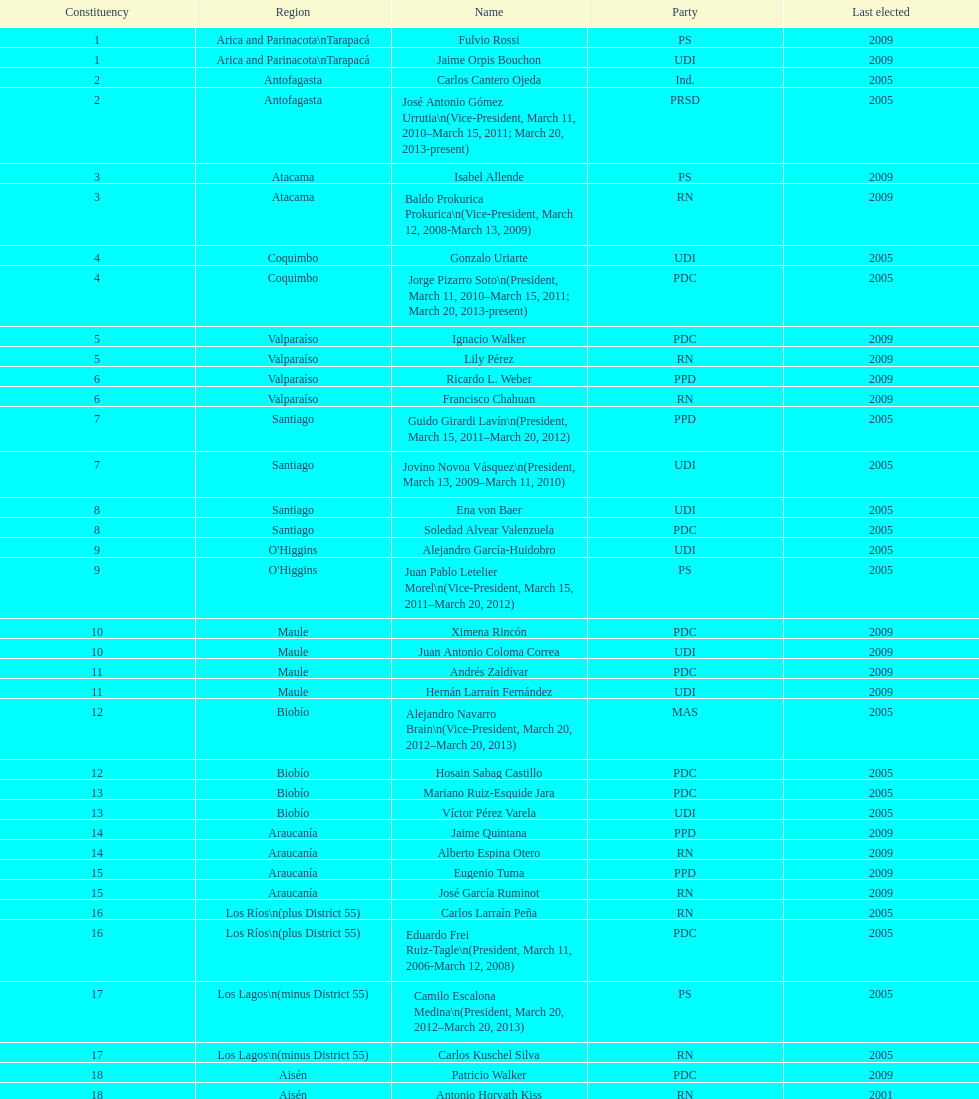Help me parse the entirety of this table. {'header': ['Constituency', 'Region', 'Name', 'Party', 'Last elected'], 'rows': [['1', 'Arica and Parinacota\\nTarapacá', 'Fulvio Rossi', 'PS', '2009'], ['1', 'Arica and Parinacota\\nTarapacá', 'Jaime Orpis Bouchon', 'UDI', '2009'], ['2', 'Antofagasta', 'Carlos Cantero Ojeda', 'Ind.', '2005'], ['2', 'Antofagasta', 'José Antonio Gómez Urrutia\\n(Vice-President, March 11, 2010–March 15, 2011; March 20, 2013-present)', 'PRSD', '2005'], ['3', 'Atacama', 'Isabel Allende', 'PS', '2009'], ['3', 'Atacama', 'Baldo Prokurica Prokurica\\n(Vice-President, March 12, 2008-March 13, 2009)', 'RN', '2009'], ['4', 'Coquimbo', 'Gonzalo Uriarte', 'UDI', '2005'], ['4', 'Coquimbo', 'Jorge Pizarro Soto\\n(President, March 11, 2010–March 15, 2011; March 20, 2013-present)', 'PDC', '2005'], ['5', 'Valparaíso', 'Ignacio Walker', 'PDC', '2009'], ['5', 'Valparaíso', 'Lily Pérez', 'RN', '2009'], ['6', 'Valparaíso', 'Ricardo L. Weber', 'PPD', '2009'], ['6', 'Valparaíso', 'Francisco Chahuan', 'RN', '2009'], ['7', 'Santiago', 'Guido Girardi Lavín\\n(President, March 15, 2011–March 20, 2012)', 'PPD', '2005'], ['7', 'Santiago', 'Jovino Novoa Vásquez\\n(President, March 13, 2009–March 11, 2010)', 'UDI', '2005'], ['8', 'Santiago', 'Ena von Baer', 'UDI', '2005'], ['8', 'Santiago', 'Soledad Alvear Valenzuela', 'PDC', '2005'], ['9', "O'Higgins", 'Alejandro García-Huidobro', 'UDI', '2005'], ['9', "O'Higgins", 'Juan Pablo Letelier Morel\\n(Vice-President, March 15, 2011–March 20, 2012)', 'PS', '2005'], ['10', 'Maule', 'Ximena Rincón', 'PDC', '2009'], ['10', 'Maule', 'Juan Antonio Coloma Correa', 'UDI', '2009'], ['11', 'Maule', 'Andrés Zaldívar', 'PDC', '2009'], ['11', 'Maule', 'Hernán Larraín Fernández', 'UDI', '2009'], ['12', 'Biobío', 'Alejandro Navarro Brain\\n(Vice-President, March 20, 2012–March 20, 2013)', 'MAS', '2005'], ['12', 'Biobío', 'Hosain Sabag Castillo', 'PDC', '2005'], ['13', 'Biobío', 'Mariano Ruiz-Esquide Jara', 'PDC', '2005'], ['13', 'Biobío', 'Víctor Pérez Varela', 'UDI', '2005'], ['14', 'Araucanía', 'Jaime Quintana', 'PPD', '2009'], ['14', 'Araucanía', 'Alberto Espina Otero', 'RN', '2009'], ['15', 'Araucanía', 'Eugenio Tuma', 'PPD', '2009'], ['15', 'Araucanía', 'José García Ruminot', 'RN', '2009'], ['16', 'Los Ríos\\n(plus District 55)', 'Carlos Larraín Peña', 'RN', '2005'], ['16', 'Los Ríos\\n(plus District 55)', 'Eduardo Frei Ruiz-Tagle\\n(President, March 11, 2006-March 12, 2008)', 'PDC', '2005'], ['17', 'Los Lagos\\n(minus District 55)', 'Camilo Escalona Medina\\n(President, March 20, 2012–March 20, 2013)', 'PS', '2005'], ['17', 'Los Lagos\\n(minus District 55)', 'Carlos Kuschel Silva', 'RN', '2005'], ['18', 'Aisén', 'Patricio Walker', 'PDC', '2009'], ['18', 'Aisén', 'Antonio Horvath Kiss', 'RN', '2001'], ['19', 'Magallanes', 'Carlos Bianchi Chelech\\n(Vice-President, March 13, 2009–March 11, 2010)', 'Ind.', '2005'], ['19', 'Magallanes', 'Pedro Muñoz Aburto', 'PS', '2005']]} How long was baldo prokurica prokurica vice-president? 1 year. 